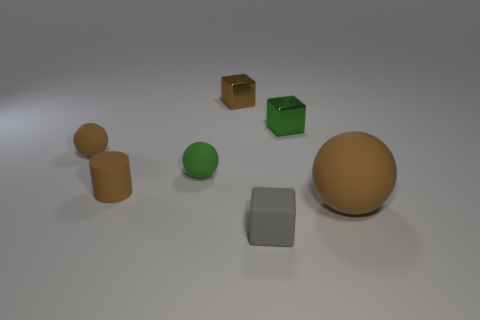Subtract all gray cylinders. Subtract all yellow blocks. How many cylinders are left? 1 Add 2 green metallic objects. How many objects exist? 9 Subtract all cylinders. How many objects are left? 6 Add 5 shiny things. How many shiny things are left? 7 Add 1 tiny green rubber spheres. How many tiny green rubber spheres exist? 2 Subtract 0 gray cylinders. How many objects are left? 7 Subtract all brown rubber cylinders. Subtract all brown metallic cubes. How many objects are left? 5 